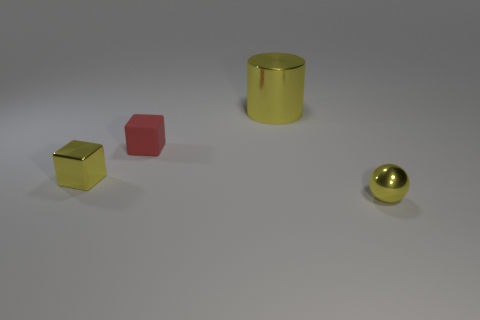Add 1 large gray cylinders. How many objects exist? 5 Subtract all cylinders. How many objects are left? 3 Add 1 small purple metal spheres. How many small purple metal spheres exist? 1 Subtract 0 purple blocks. How many objects are left? 4 Subtract all gray metallic cylinders. Subtract all tiny matte things. How many objects are left? 3 Add 3 small yellow spheres. How many small yellow spheres are left? 4 